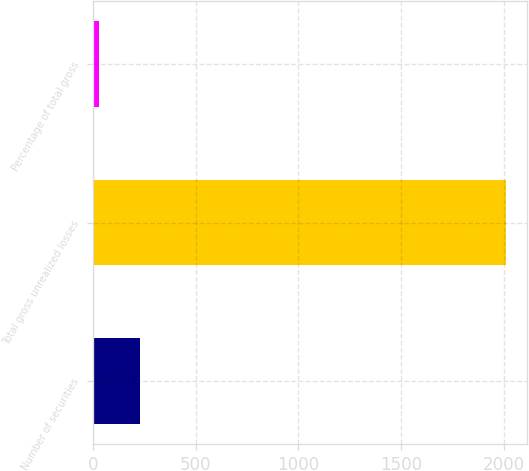Convert chart to OTSL. <chart><loc_0><loc_0><loc_500><loc_500><bar_chart><fcel>Number of securities<fcel>Total gross unrealized losses<fcel>Percentage of total gross<nl><fcel>229.3<fcel>2014<fcel>31<nl></chart> 